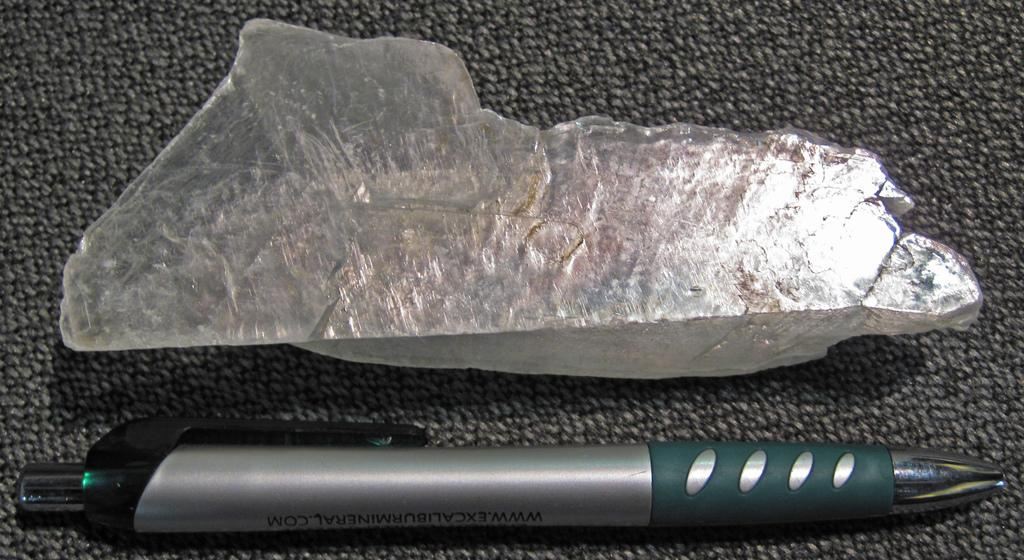What object made of stone can be seen in the image? There is a stone in the image. What writing instrument is present in the image? There is a pen in the image. What is the color scheme of the surface in the image? The surface in the image is black and grey in color. How deep is the hole in the stone in the image? There is no hole present in the stone in the image. What type of watch is the yak wearing in the image? There is no yak present in the image, and therefore no watch or any other accessory can be observed. 